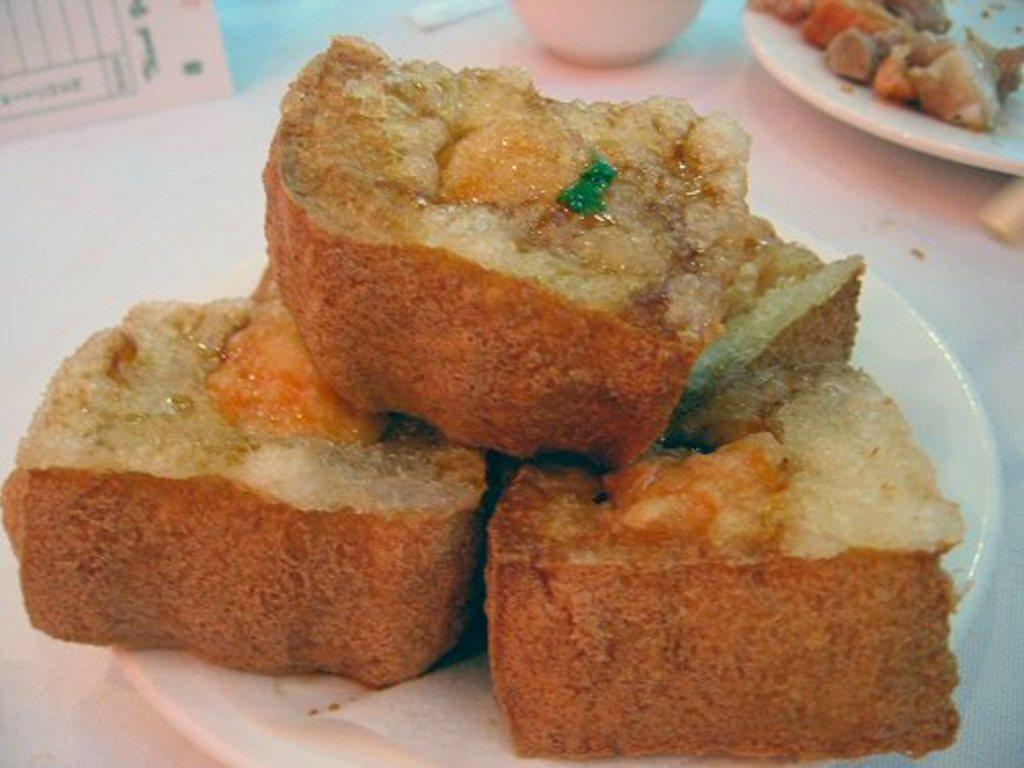What is on the plate that is on the platform in the image? There are food items on a plate on the platform in the image. What else can be seen on the platform besides the plate with food items? There are objects on the platform. Are there any other plates with food items on the platform? Yes, there is another food item on a plate on the platform. What type of bell can be heard ringing in the image? There is no bell present in the image, so it is not possible to hear it ringing. 